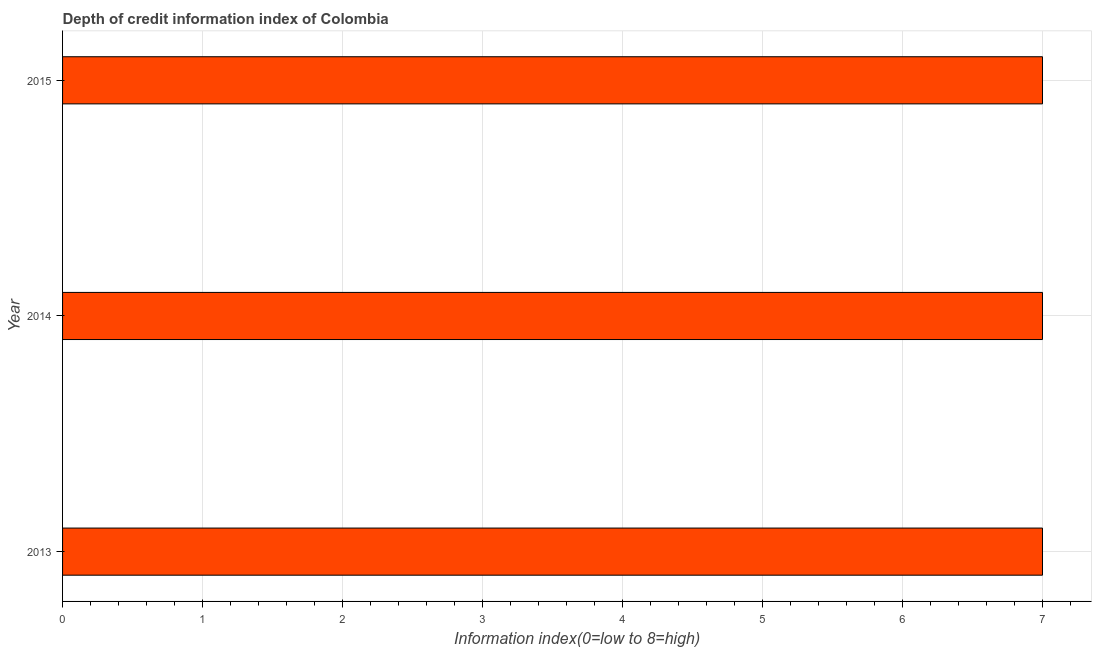Does the graph contain any zero values?
Your response must be concise. No. What is the title of the graph?
Provide a short and direct response. Depth of credit information index of Colombia. What is the label or title of the X-axis?
Provide a succinct answer. Information index(0=low to 8=high). What is the label or title of the Y-axis?
Your answer should be very brief. Year. What is the sum of the depth of credit information index?
Give a very brief answer. 21. What is the difference between the depth of credit information index in 2014 and 2015?
Keep it short and to the point. 0. What is the average depth of credit information index per year?
Keep it short and to the point. 7. In how many years, is the depth of credit information index greater than 3.8 ?
Your answer should be very brief. 3. What is the ratio of the depth of credit information index in 2013 to that in 2014?
Provide a short and direct response. 1. Is the depth of credit information index in 2013 less than that in 2015?
Your answer should be compact. No. Is the difference between the depth of credit information index in 2013 and 2014 greater than the difference between any two years?
Keep it short and to the point. Yes. What is the difference between the highest and the lowest depth of credit information index?
Your response must be concise. 0. In how many years, is the depth of credit information index greater than the average depth of credit information index taken over all years?
Your response must be concise. 0. How many bars are there?
Your response must be concise. 3. What is the difference between two consecutive major ticks on the X-axis?
Offer a very short reply. 1. Are the values on the major ticks of X-axis written in scientific E-notation?
Your answer should be compact. No. What is the Information index(0=low to 8=high) of 2013?
Keep it short and to the point. 7. What is the Information index(0=low to 8=high) of 2014?
Keep it short and to the point. 7. What is the Information index(0=low to 8=high) in 2015?
Offer a very short reply. 7. What is the difference between the Information index(0=low to 8=high) in 2013 and 2014?
Give a very brief answer. 0. What is the ratio of the Information index(0=low to 8=high) in 2013 to that in 2014?
Your answer should be very brief. 1. What is the ratio of the Information index(0=low to 8=high) in 2014 to that in 2015?
Give a very brief answer. 1. 